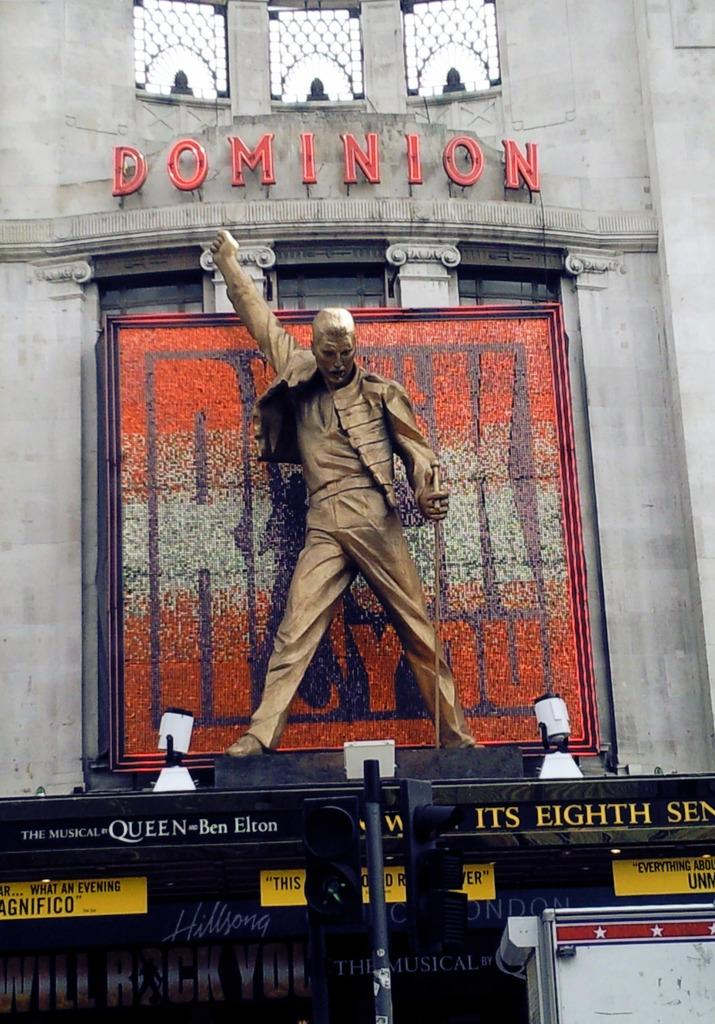<image>
Offer a succinct explanation of the picture presented. A sign at the Dominion has the word "Queen" on it. 